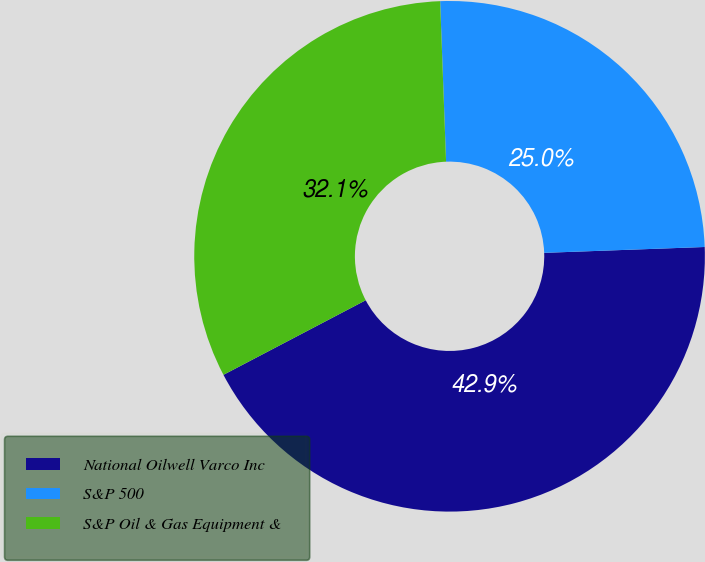Convert chart to OTSL. <chart><loc_0><loc_0><loc_500><loc_500><pie_chart><fcel>National Oilwell Varco Inc<fcel>S&P 500<fcel>S&P Oil & Gas Equipment &<nl><fcel>42.9%<fcel>25.01%<fcel>32.1%<nl></chart> 